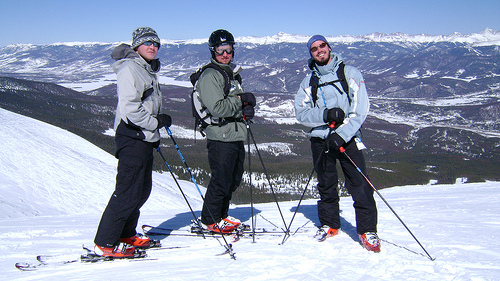Please provide a short description for this region: [0.75, 0.28, 1.0, 0.57]. This region showcases a breathtaking view of a snowy mountain range under a clear blue sky, offering a sense of vast, untouched wilderness. 